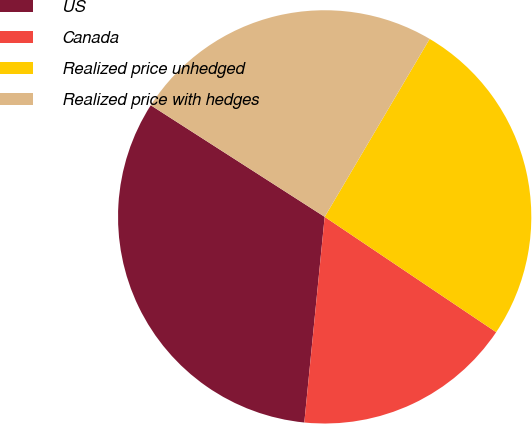<chart> <loc_0><loc_0><loc_500><loc_500><pie_chart><fcel>US<fcel>Canada<fcel>Realized price unhedged<fcel>Realized price with hedges<nl><fcel>32.51%<fcel>17.15%<fcel>25.94%<fcel>24.4%<nl></chart> 